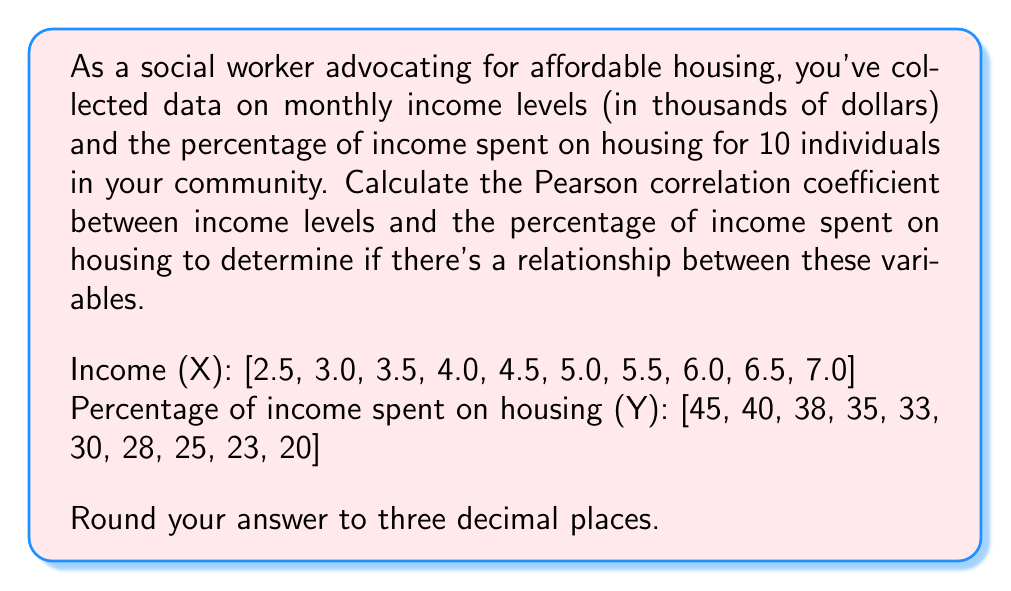Solve this math problem. To calculate the Pearson correlation coefficient (r), we'll use the formula:

$$ r = \frac{n\sum xy - (\sum x)(\sum y)}{\sqrt{[n\sum x^2 - (\sum x)^2][n\sum y^2 - (\sum y)^2]}} $$

Where:
n = number of pairs of data
x = income levels
y = percentage of income spent on housing

Step 1: Calculate the required sums:
$\sum x = 47.5$
$\sum y = 317$
$\sum xy = 1,431.5$
$\sum x^2 = 244.75$
$\sum y^2 = 10,853$

Step 2: Substitute these values into the formula:

$$ r = \frac{10(1,431.5) - (47.5)(317)}{\sqrt{[10(244.75) - (47.5)^2][10(10,853) - (317)^2]}} $$

Step 3: Simplify:

$$ r = \frac{14,315 - 15,057.5}{\sqrt{(2,447.5 - 2,256.25)(108,530 - 100,489)}} $$

$$ r = \frac{-742.5}{\sqrt{(191.25)(8,041)}} $$

$$ r = \frac{-742.5}{\sqrt{1,537,841.25}} $$

$$ r = \frac{-742.5}{1,239.694} $$

$$ r = -0.598918 $$

Step 4: Round to three decimal places:

$$ r \approx -0.599 $$
Answer: The Pearson correlation coefficient between income levels and the percentage of income spent on housing is approximately -0.599. 